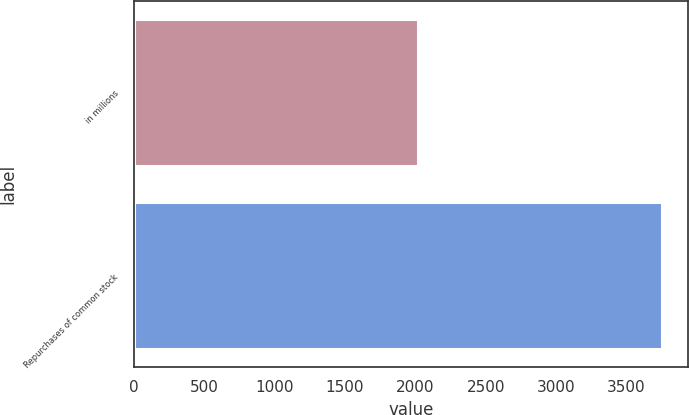Convert chart. <chart><loc_0><loc_0><loc_500><loc_500><bar_chart><fcel>in millions<fcel>Repurchases of common stock<nl><fcel>2017<fcel>3750<nl></chart> 